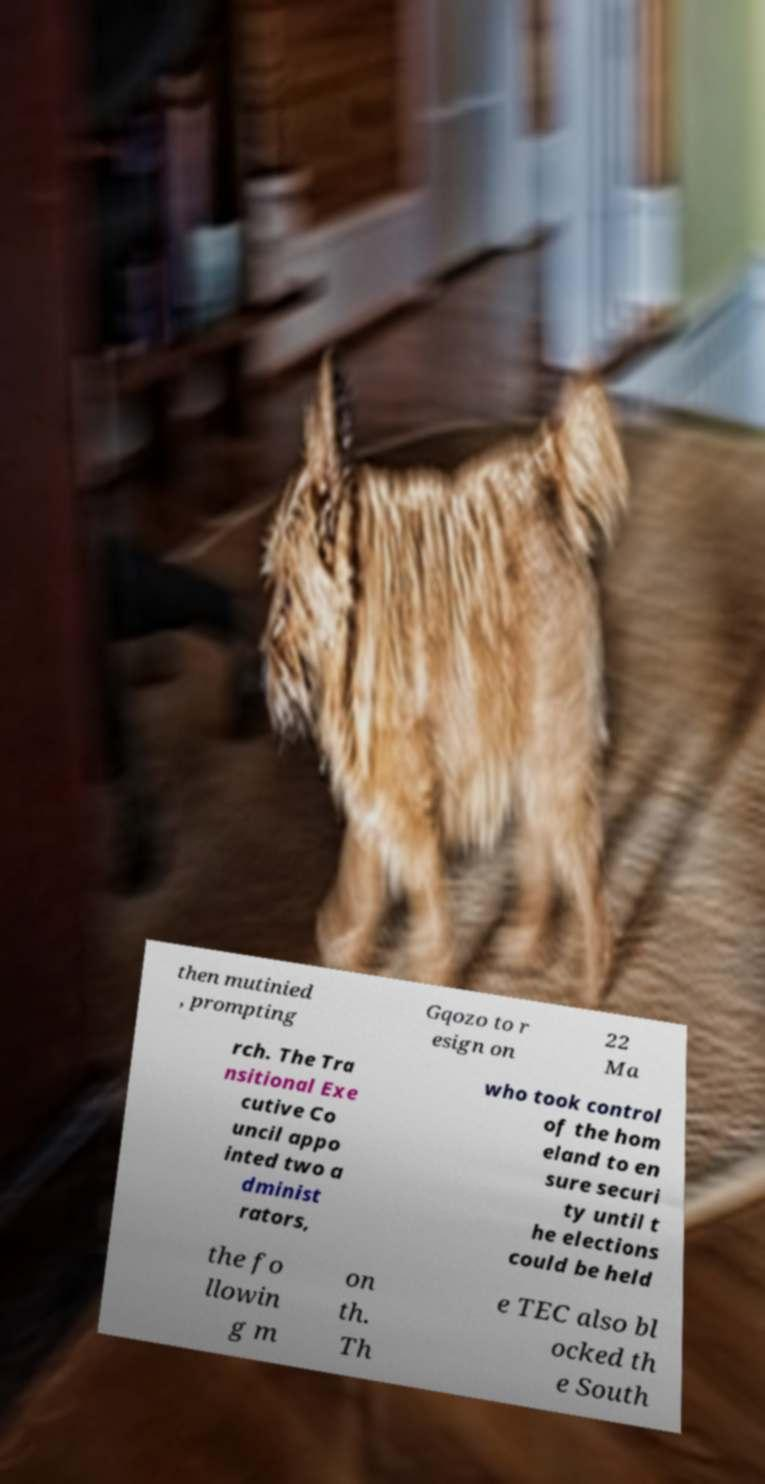Could you assist in decoding the text presented in this image and type it out clearly? then mutinied , prompting Gqozo to r esign on 22 Ma rch. The Tra nsitional Exe cutive Co uncil appo inted two a dminist rators, who took control of the hom eland to en sure securi ty until t he elections could be held the fo llowin g m on th. Th e TEC also bl ocked th e South 